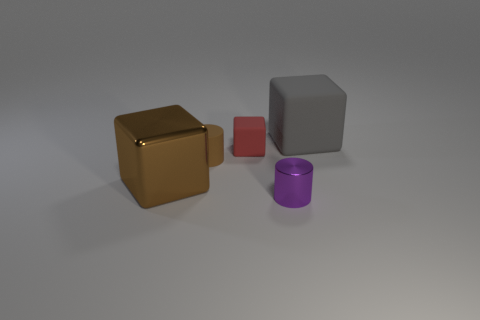How many objects are big gray matte things or purple shiny cylinders?
Provide a short and direct response. 2. What number of other things are the same color as the tiny metallic object?
Provide a short and direct response. 0. The purple metal object that is the same size as the brown cylinder is what shape?
Keep it short and to the point. Cylinder. There is a big object right of the large brown metallic thing; what is its color?
Your answer should be very brief. Gray. What number of things are either big things in front of the big gray block or large blocks that are in front of the tiny rubber cylinder?
Ensure brevity in your answer.  1. Is the size of the red rubber block the same as the gray matte thing?
Your answer should be compact. No. How many cylinders are large gray things or tiny brown objects?
Offer a terse response. 1. What number of things are both in front of the tiny matte cube and on the right side of the big brown cube?
Ensure brevity in your answer.  2. Is the size of the red matte thing the same as the metallic object that is right of the brown matte cylinder?
Give a very brief answer. Yes. There is a big thing that is left of the matte block that is on the right side of the small rubber block; are there any small cylinders that are in front of it?
Your answer should be compact. Yes. 